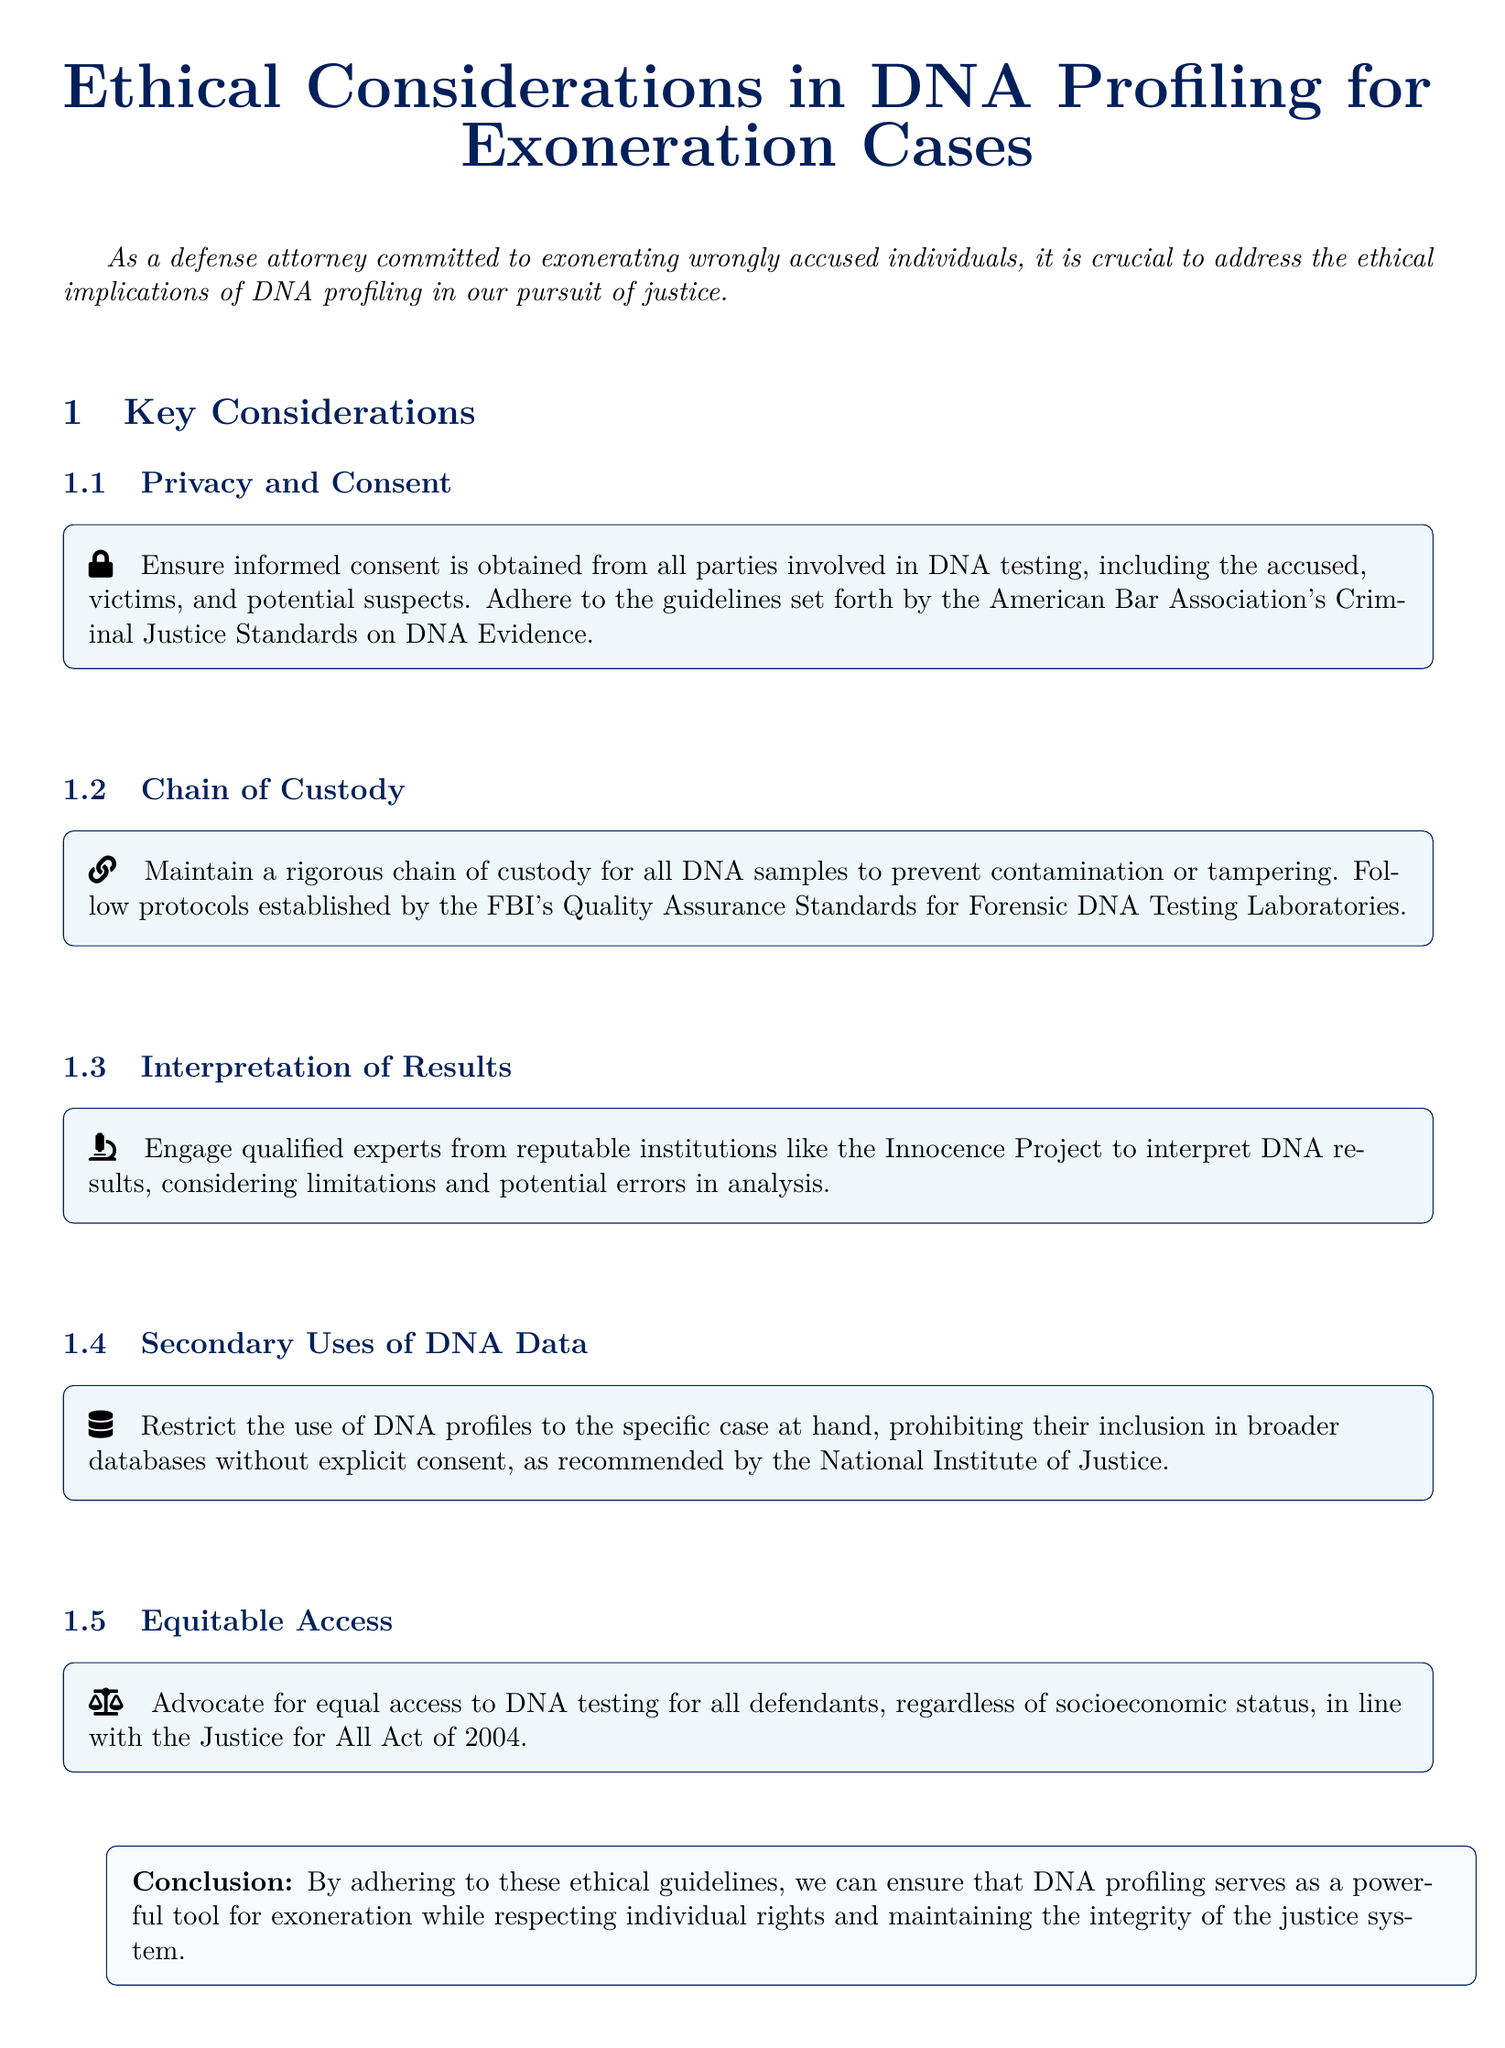What is the title of the document? The title is prominently displayed at the beginning of the document.
Answer: Ethical Considerations in DNA Profiling for Exoneration Cases What does the document recommend obtaining from all parties involved in DNA testing? The document emphasizes the importance of obtaining consent in the context of DNA testing.
Answer: Informed consent Which organization's standards should be adhered to according to the privacy and consent section? The section specifically references guidelines related to DNA evidence from a notable organization.
Answer: American Bar Association What is crucial to maintain to prevent contamination of DNA samples? The document highlights a specific practice to ensure the integrity of DNA samples.
Answer: Chain of custody Who is suggested to interpret DNA results? The document identifies a prominent organization that provides expertise in interpreting DNA results.
Answer: Innocence Project What act does the document mention that advocates for equal access to DNA testing? The document references a specific act concerning DNA testing access.
Answer: Justice for All Act of 2004 What must be restricted according to the secondary uses of DNA data? The section discusses limitations regarding the utilization of DNA profiles.
Answer: Broader databases without explicit consent What is the conclusion's main focus regarding ethical guidelines? The conclusion emphasizes the overarching goal of adhering to ethical standards in the context of DNA profiling.
Answer: Individual rights and integrity of the justice system 